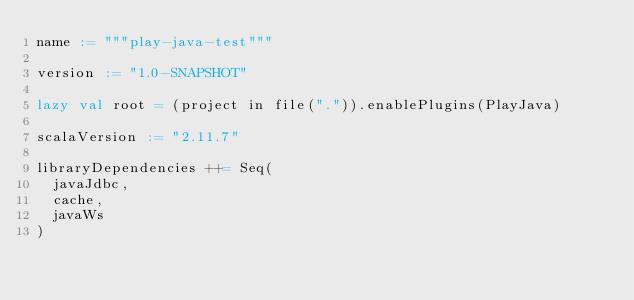<code> <loc_0><loc_0><loc_500><loc_500><_Scala_>name := """play-java-test"""

version := "1.0-SNAPSHOT"

lazy val root = (project in file(".")).enablePlugins(PlayJava)

scalaVersion := "2.11.7"

libraryDependencies ++= Seq(
  javaJdbc,
  cache,
  javaWs
)
</code> 